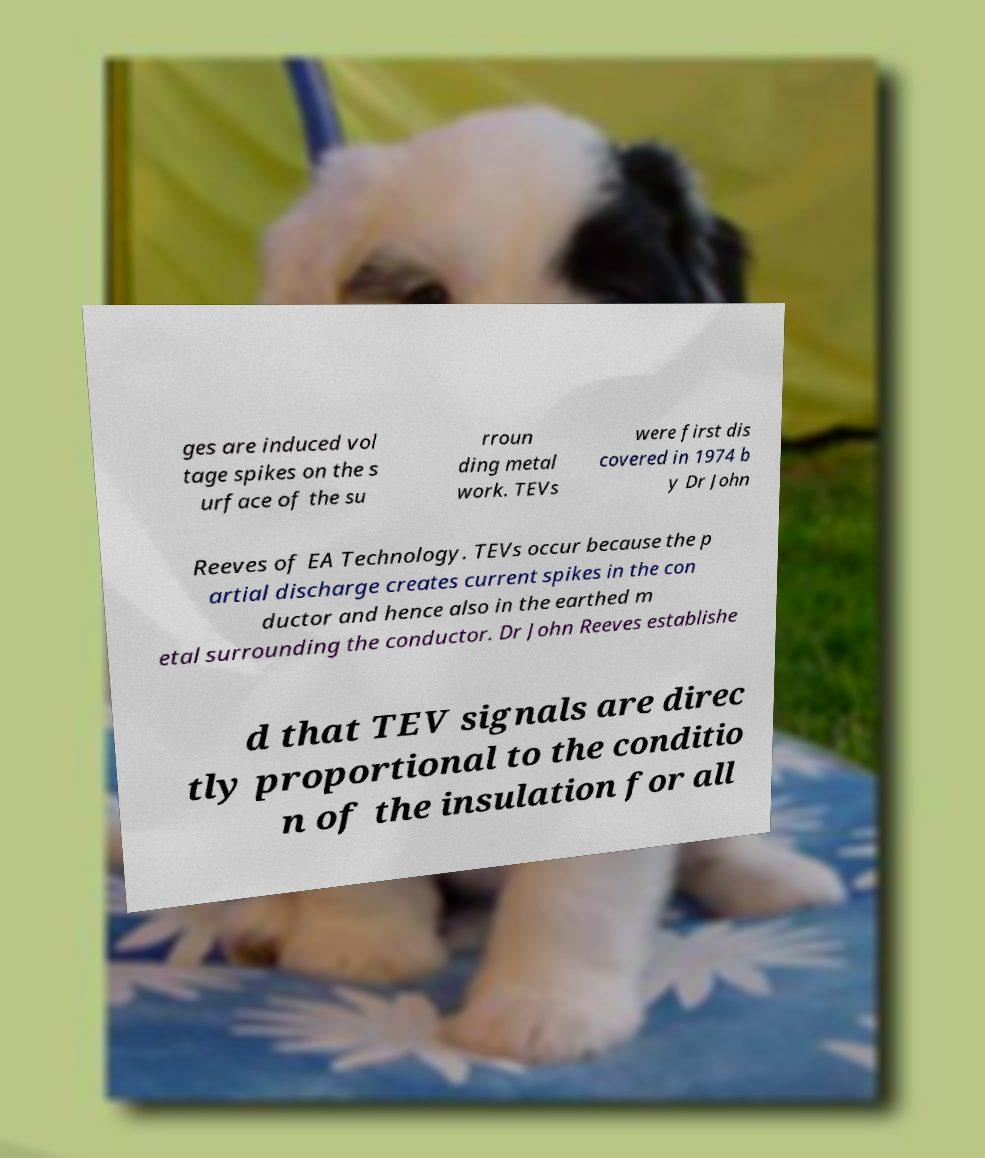There's text embedded in this image that I need extracted. Can you transcribe it verbatim? ges are induced vol tage spikes on the s urface of the su rroun ding metal work. TEVs were first dis covered in 1974 b y Dr John Reeves of EA Technology. TEVs occur because the p artial discharge creates current spikes in the con ductor and hence also in the earthed m etal surrounding the conductor. Dr John Reeves establishe d that TEV signals are direc tly proportional to the conditio n of the insulation for all 